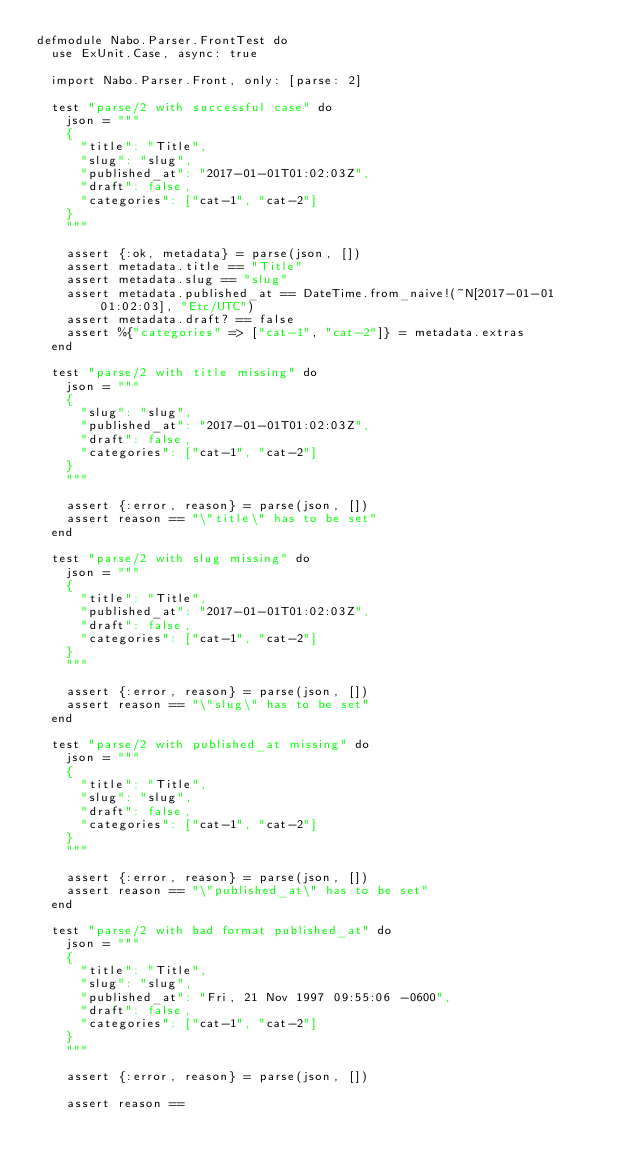<code> <loc_0><loc_0><loc_500><loc_500><_Elixir_>defmodule Nabo.Parser.FrontTest do
  use ExUnit.Case, async: true

  import Nabo.Parser.Front, only: [parse: 2]

  test "parse/2 with successful case" do
    json = """
    {
      "title": "Title",
      "slug": "slug",
      "published_at": "2017-01-01T01:02:03Z",
      "draft": false,
      "categories": ["cat-1", "cat-2"]
    }
    """

    assert {:ok, metadata} = parse(json, [])
    assert metadata.title == "Title"
    assert metadata.slug == "slug"
    assert metadata.published_at == DateTime.from_naive!(~N[2017-01-01 01:02:03], "Etc/UTC")
    assert metadata.draft? == false
    assert %{"categories" => ["cat-1", "cat-2"]} = metadata.extras
  end

  test "parse/2 with title missing" do
    json = """
    {
      "slug": "slug",
      "published_at": "2017-01-01T01:02:03Z",
      "draft": false,
      "categories": ["cat-1", "cat-2"]
    }
    """

    assert {:error, reason} = parse(json, [])
    assert reason == "\"title\" has to be set"
  end

  test "parse/2 with slug missing" do
    json = """
    {
      "title": "Title",
      "published_at": "2017-01-01T01:02:03Z",
      "draft": false,
      "categories": ["cat-1", "cat-2"]
    }
    """

    assert {:error, reason} = parse(json, [])
    assert reason == "\"slug\" has to be set"
  end

  test "parse/2 with published_at missing" do
    json = """
    {
      "title": "Title",
      "slug": "slug",
      "draft": false,
      "categories": ["cat-1", "cat-2"]
    }
    """

    assert {:error, reason} = parse(json, [])
    assert reason == "\"published_at\" has to be set"
  end

  test "parse/2 with bad format published_at" do
    json = """
    {
      "title": "Title",
      "slug": "slug",
      "published_at": "Fri, 21 Nov 1997 09:55:06 -0600",
      "draft": false,
      "categories": ["cat-1", "cat-2"]
    }
    """

    assert {:error, reason} = parse(json, [])

    assert reason ==</code> 